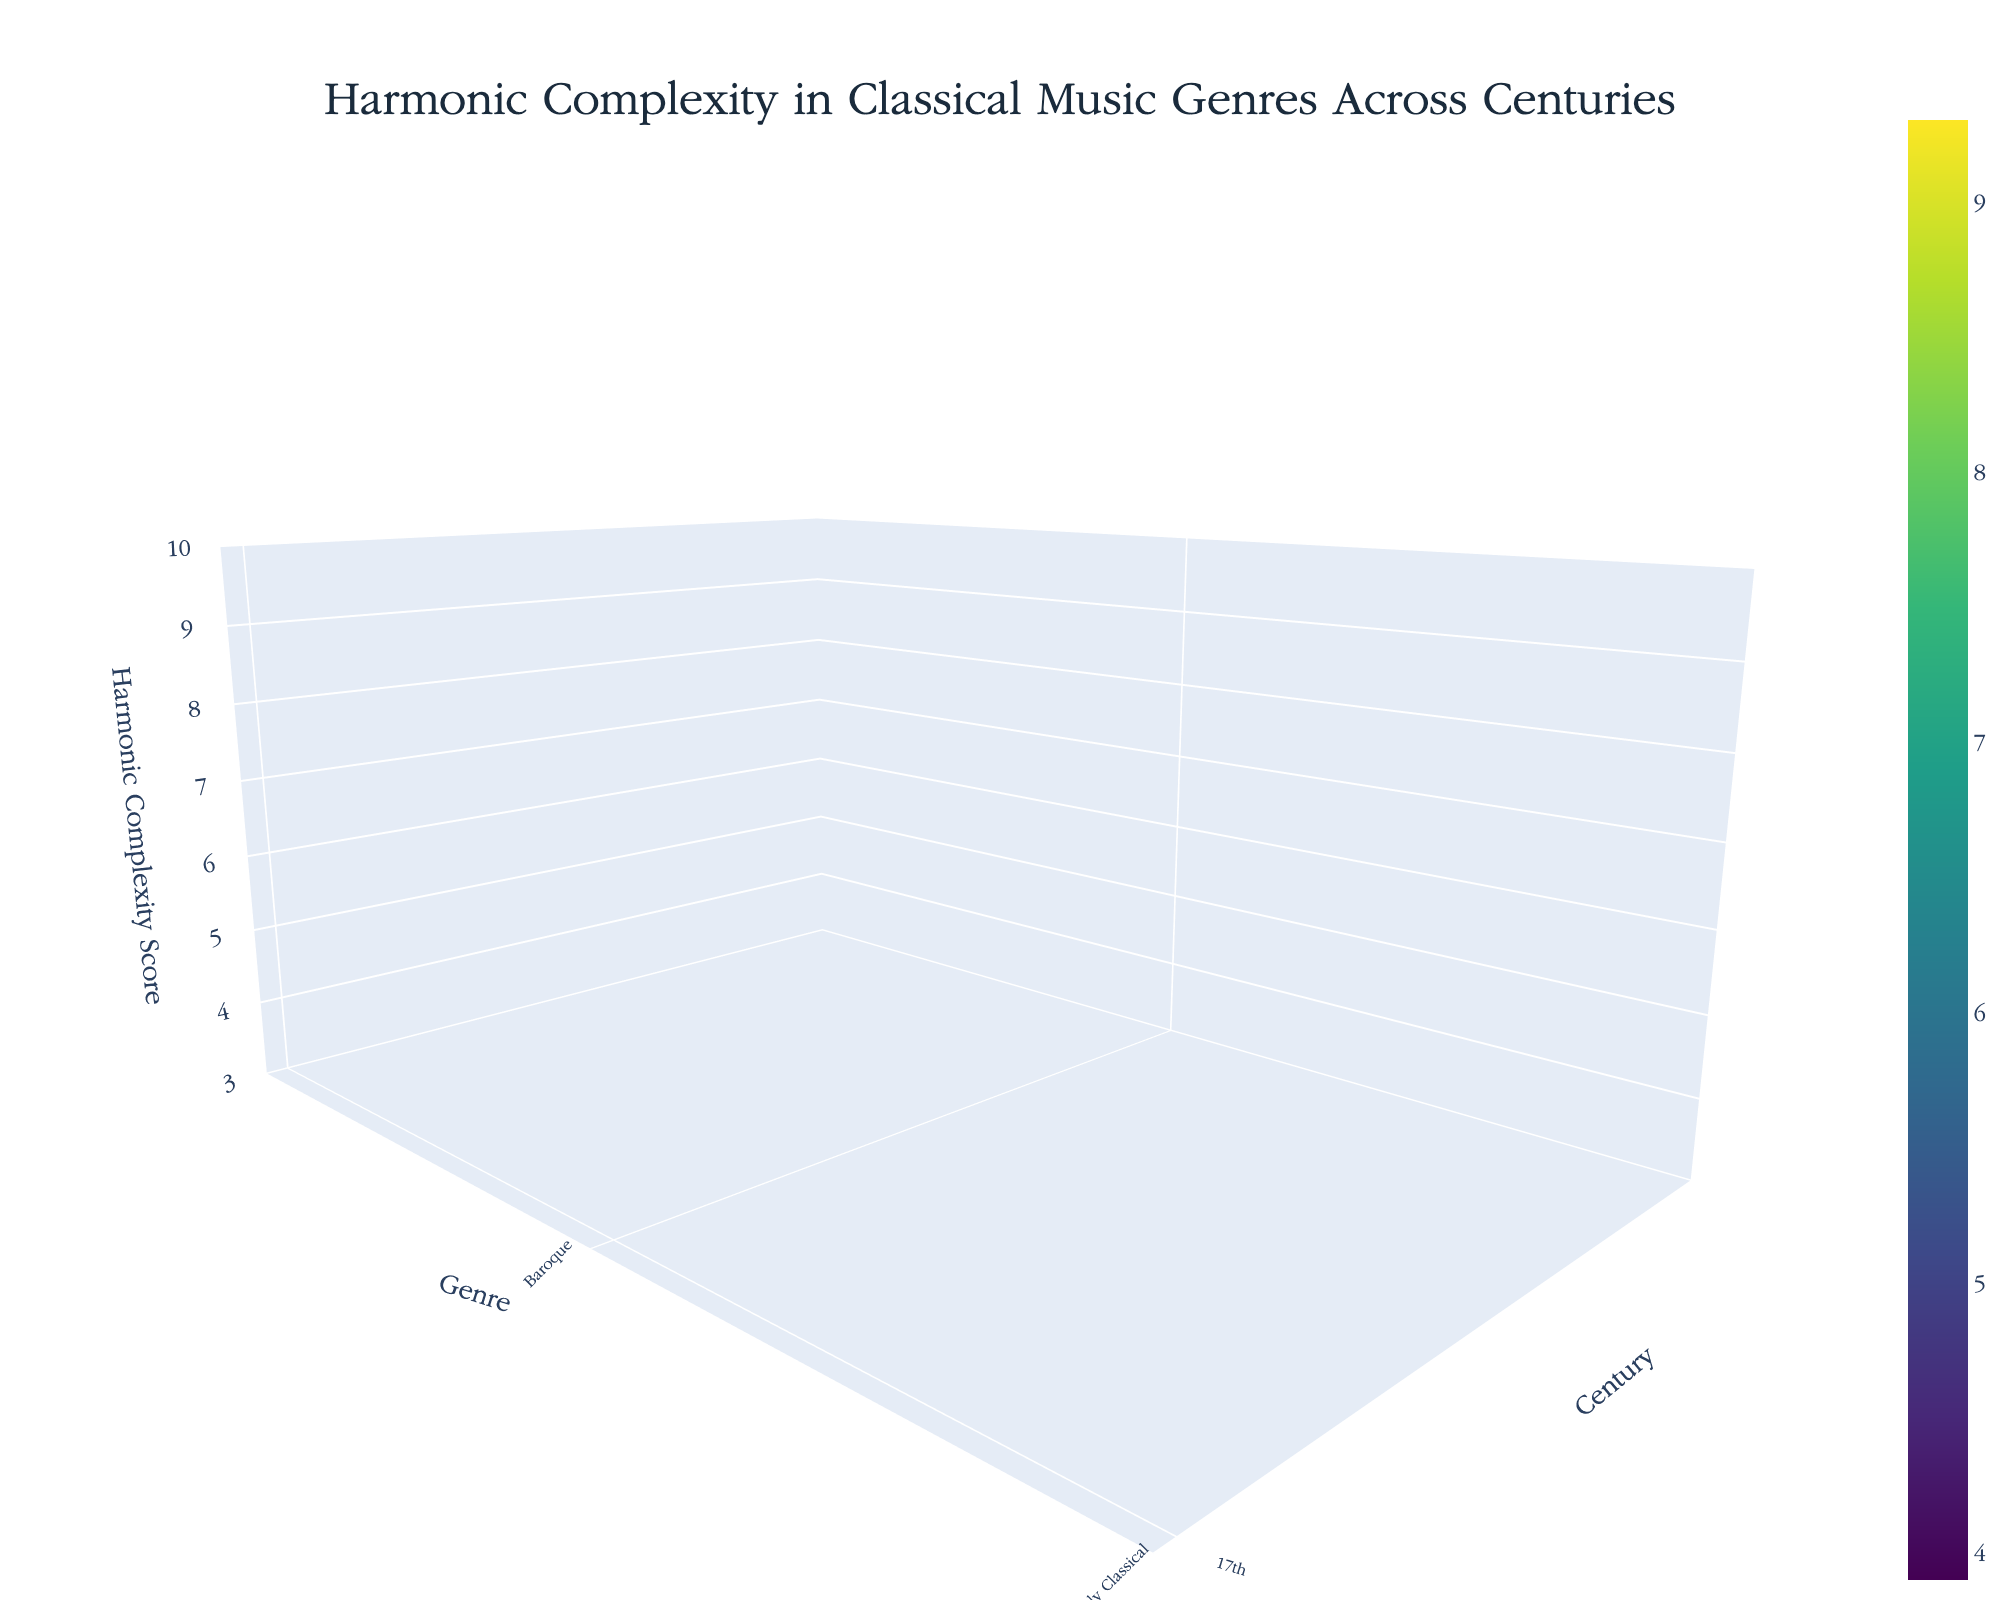What's the title of the plot? The title is positioned at the top of the plot and provides an overview of its content, which is about harmonic complexity in classical music genres across centuries.
Answer: Harmonic Complexity in Classical Music Genres Across Centuries What does the y-axis represent? The y-axis is labeled "Century," indicating that it represents the different centuries over which the harmonic complexity is plotted.
Answer: Century Which century shows the highest overall harmonic complexity? By observing the plot, the highest peaks in the z-axis, which represents harmonic complexity, occur predominantly in the 21st century.
Answer: 21st century How does the harmonic complexity of Baroque music change from the 17th to the 18th century? Look at the values on the z-axis for Baroque music across the centuries. In the 17th century, the score is 6.2, and in the 18th century, it increases to 6.8.
Answer: It increases Which genre has the lowest harmonic complexity score in the 20th century? By examining the 20th-century section and comparing the z-axis values (harmonic complexity scores) for each genre within it, Minimalism shows the lowest score of 3.9.
Answer: Minimalism Compare the harmonic complexity scores between Romantic and Impressionist music in the 19th century. Which is higher and by how much? Romantic music has a score of 7.9, while Impressionist music scores 8.4 in the 19th century. The difference is calculated by subtracting the lower score from the higher score: 8.4 - 7.9 = 0.5.
Answer: Impressionist by 0.5 What is the average harmonic complexity score for all genres in the 18th century? List the scores for each genre in the 18th century (Baroque: 6.8, Classical: 5.5, Galant: 4.3), sum them up, and divide by the number of genres: (6.8 + 5.5 + 4.3) / 3 = 5.5333.
Answer: 5.53 What patterns can you observe about the evolution of harmonic complexity from the 17th to the 21st century across all genres? Notice the trend lines of the z-axis values across centuries, consolidating observations: there is a general increase in complexity over time, with notable peaks in the 19th and 21st centuries, suggesting periods of significant evolution in harmonic structure.
Answer: General increase with peaks in the 19th and 21st centuries 